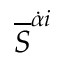Convert formula to latex. <formula><loc_0><loc_0><loc_500><loc_500>{ \overline { S } } ^ { { \dot { \alpha } } i }</formula> 